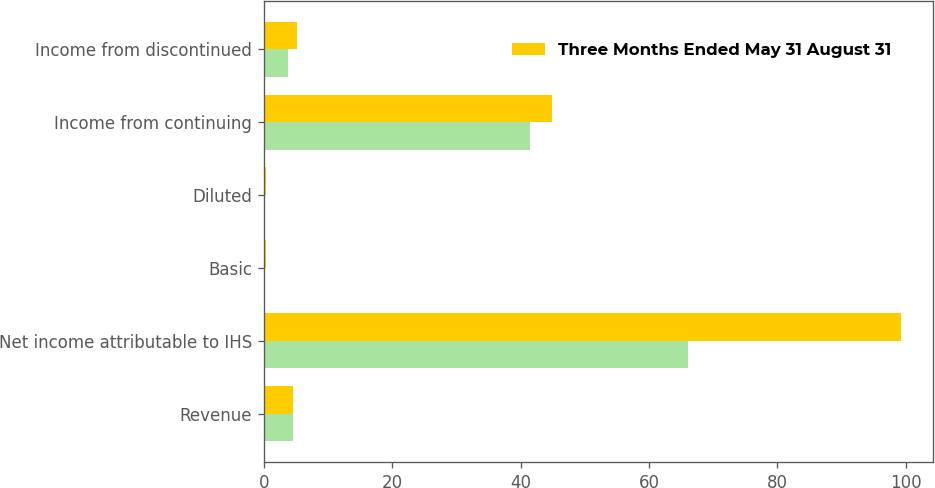Convert chart. <chart><loc_0><loc_0><loc_500><loc_500><stacked_bar_chart><ecel><fcel>Revenue<fcel>Net income attributable to IHS<fcel>Basic<fcel>Diluted<fcel>Income from continuing<fcel>Income from discontinued<nl><fcel>nan<fcel>4.5<fcel>66<fcel>0.16<fcel>0.16<fcel>41.4<fcel>3.8<nl><fcel>Three Months Ended May 31 August 31<fcel>4.5<fcel>99.3<fcel>0.25<fcel>0.24<fcel>44.8<fcel>5.2<nl></chart> 